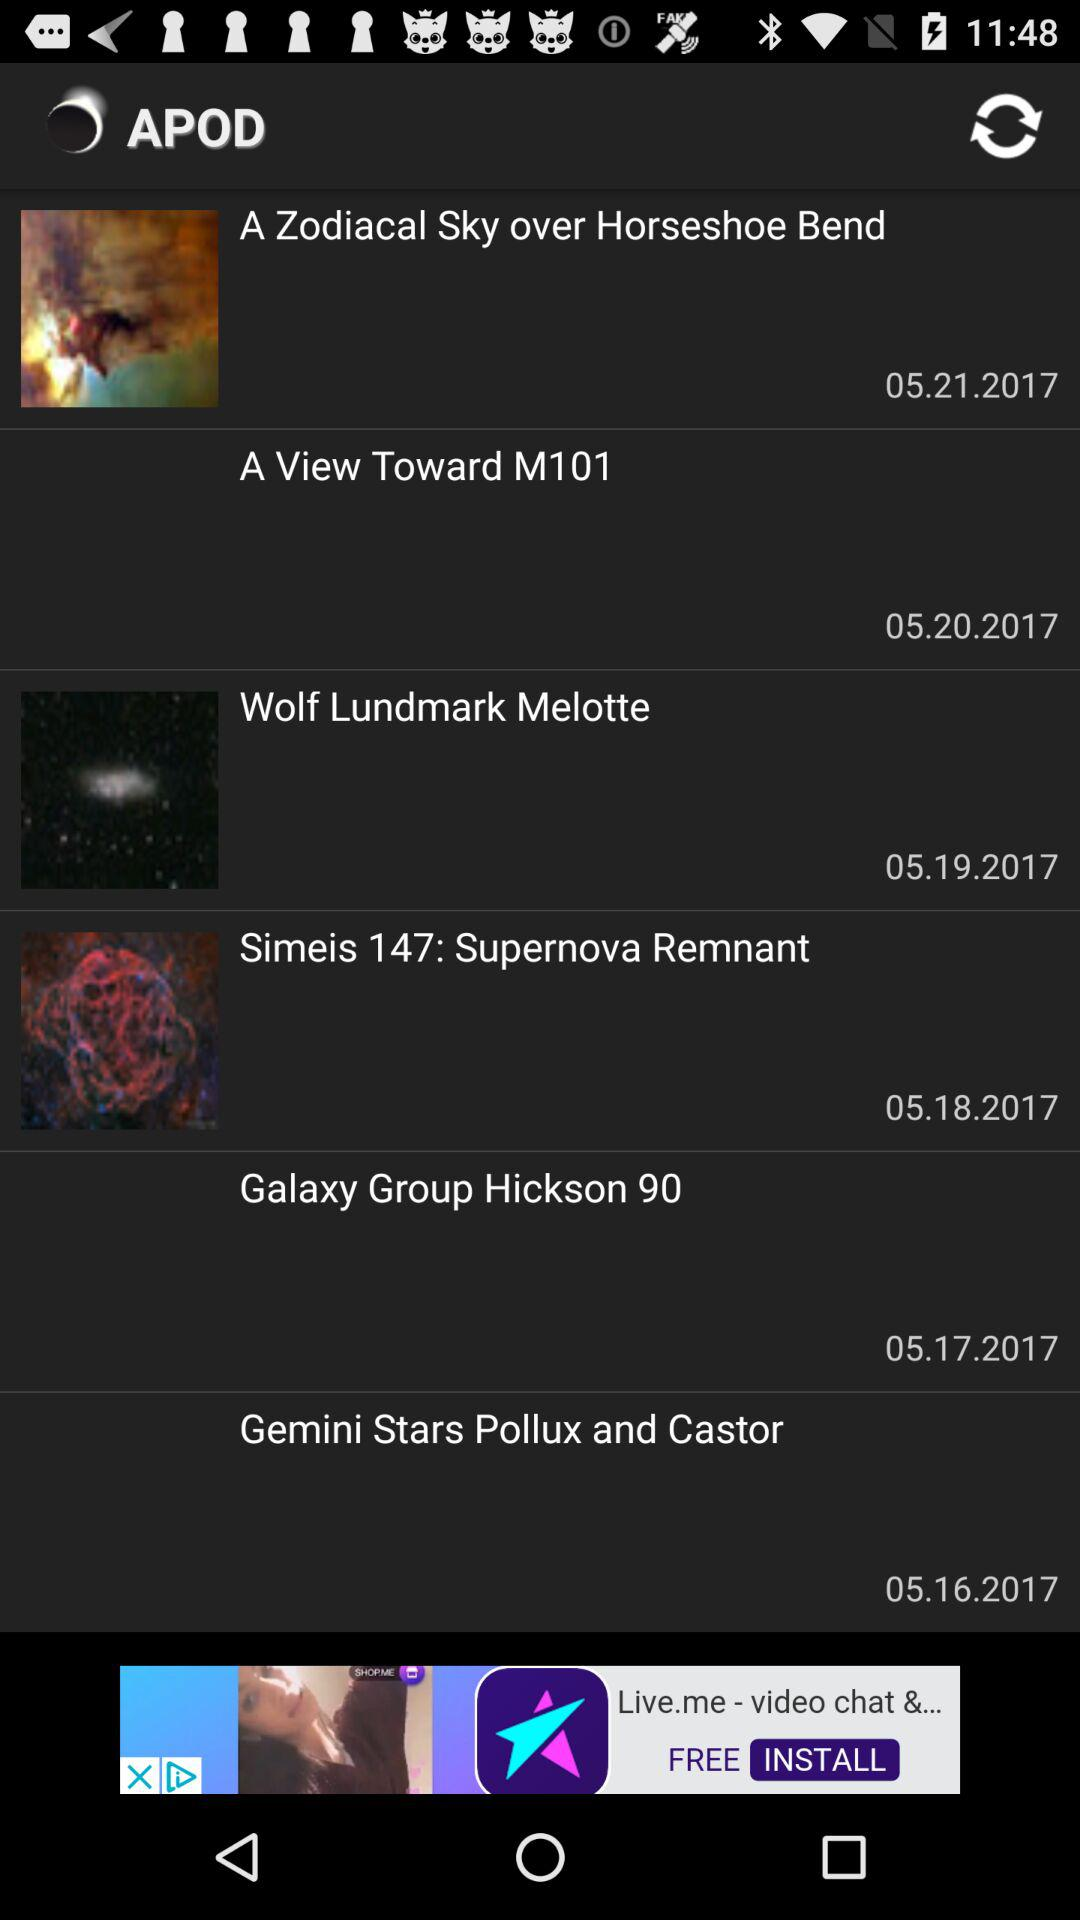How many APODs are there?
Answer the question using a single word or phrase. 6 